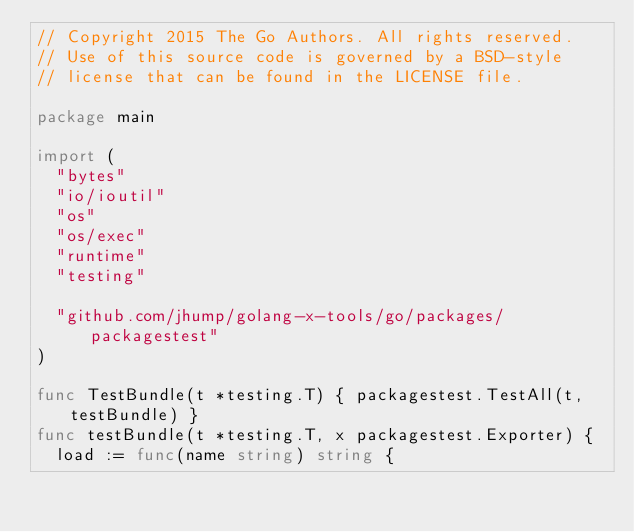Convert code to text. <code><loc_0><loc_0><loc_500><loc_500><_Go_>// Copyright 2015 The Go Authors. All rights reserved.
// Use of this source code is governed by a BSD-style
// license that can be found in the LICENSE file.

package main

import (
	"bytes"
	"io/ioutil"
	"os"
	"os/exec"
	"runtime"
	"testing"

	"github.com/jhump/golang-x-tools/go/packages/packagestest"
)

func TestBundle(t *testing.T) { packagestest.TestAll(t, testBundle) }
func testBundle(t *testing.T, x packagestest.Exporter) {
	load := func(name string) string {</code> 